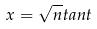<formula> <loc_0><loc_0><loc_500><loc_500>x = \sqrt { n } t a n t</formula> 